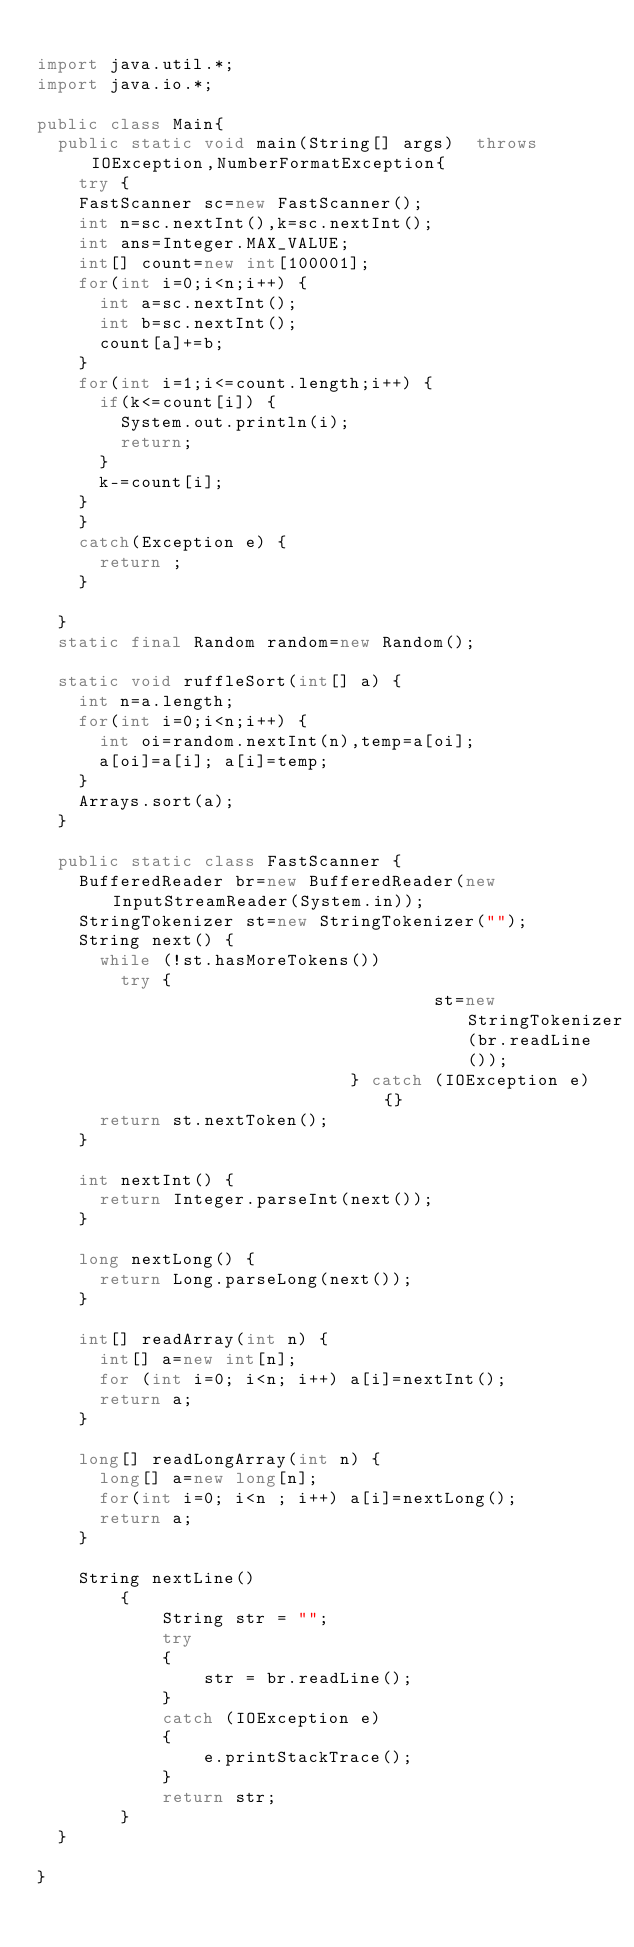Convert code to text. <code><loc_0><loc_0><loc_500><loc_500><_Java_>
import java.util.*;
import java.io.*;

public class Main{
	public static void main(String[] args)  throws IOException,NumberFormatException{
		try {
		FastScanner sc=new FastScanner();
		int n=sc.nextInt(),k=sc.nextInt();
		int ans=Integer.MAX_VALUE;
		int[] count=new int[100001];
		for(int i=0;i<n;i++) {
			int a=sc.nextInt();
			int b=sc.nextInt();
			count[a]+=b;
		}
		for(int i=1;i<=count.length;i++) {
			if(k<=count[i]) {
				System.out.println(i);
				return;
			}
			k-=count[i];
		}
		}
		catch(Exception e) {
			return ;
		}
		
	}
	static final Random random=new Random();
	
	static void ruffleSort(int[] a) {
		int n=a.length;
		for(int i=0;i<n;i++) {
			int oi=random.nextInt(n),temp=a[oi];
			a[oi]=a[i]; a[i]=temp;
		}
		Arrays.sort(a);
	}
	
	public static class FastScanner {
		BufferedReader br=new BufferedReader(new InputStreamReader(System.in));
		StringTokenizer st=new StringTokenizer("");
		String next() {
			while (!st.hasMoreTokens())
				try { 
                                      st=new StringTokenizer(br.readLine());				               
                              } catch (IOException e) {}
			return st.nextToken();
		}
		
		int nextInt() {
			return Integer.parseInt(next());
		}
		
		long nextLong() {
			return Long.parseLong(next());
		}
		
		int[] readArray(int n) {
			int[] a=new int[n];
			for (int i=0; i<n; i++) a[i]=nextInt();
			return a;
		}
		
		long[] readLongArray(int n) {
			long[] a=new long[n];
			for(int i=0; i<n ; i++) a[i]=nextLong();
			return a;
		}
		
		String nextLine() 
        { 
            String str = ""; 
            try
            { 
                str = br.readLine(); 
            } 
            catch (IOException e) 
            { 
                e.printStackTrace(); 
            } 
            return str; 
        } 
	}

}
</code> 